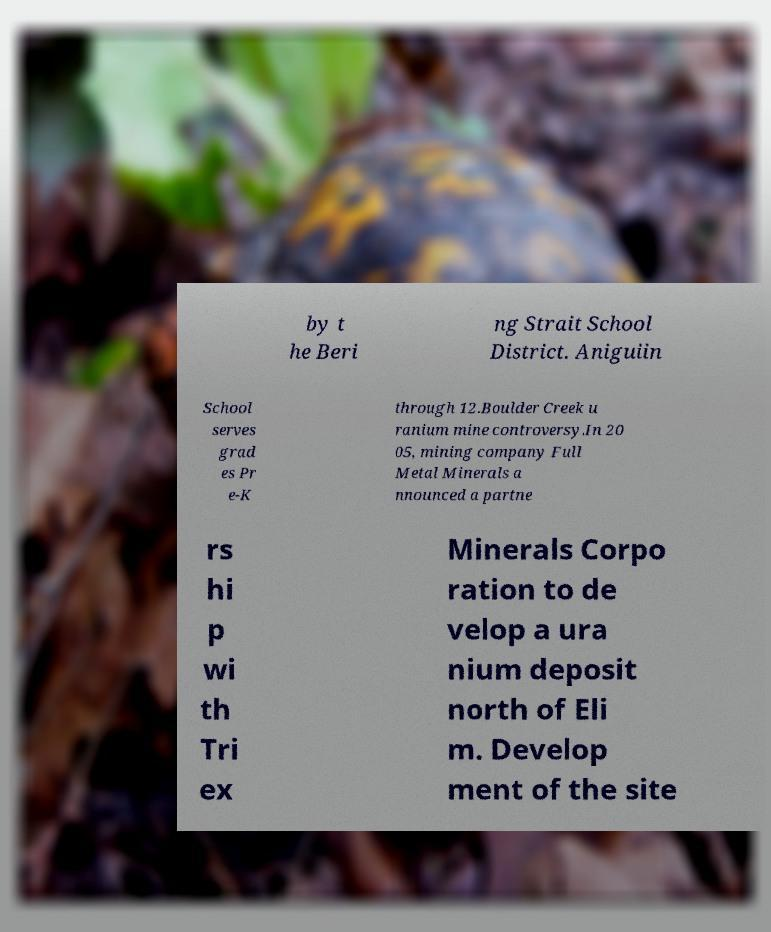What messages or text are displayed in this image? I need them in a readable, typed format. by t he Beri ng Strait School District. Aniguiin School serves grad es Pr e-K through 12.Boulder Creek u ranium mine controversy.In 20 05, mining company Full Metal Minerals a nnounced a partne rs hi p wi th Tri ex Minerals Corpo ration to de velop a ura nium deposit north of Eli m. Develop ment of the site 